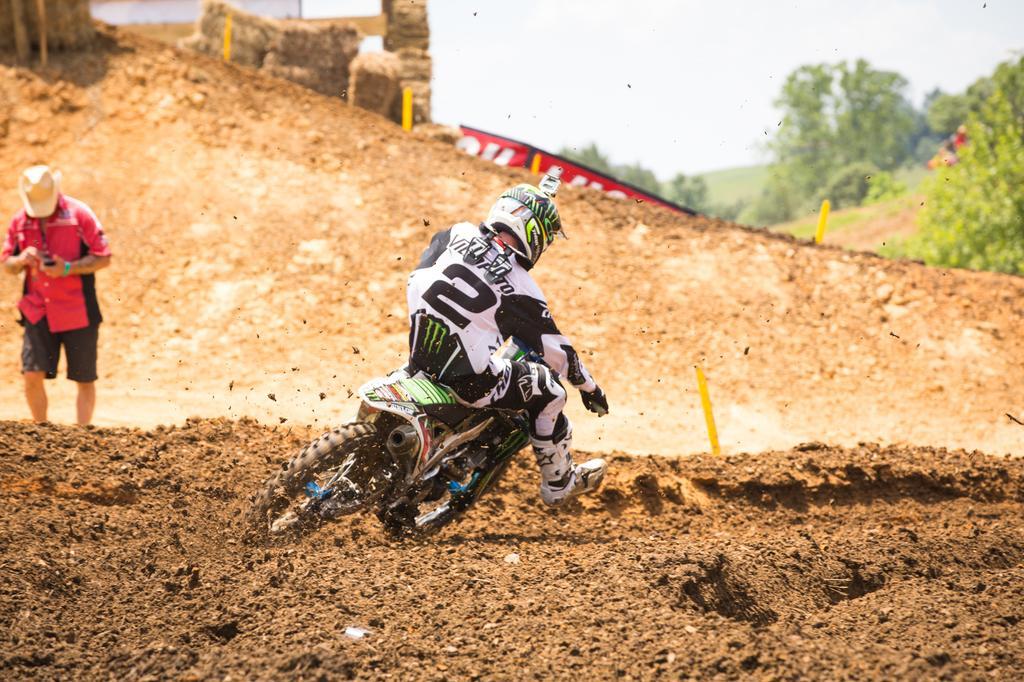Can you describe this image briefly? There are two people in the picture, the one is with red shirt and black short has a hat and the other one is riding the bicycle in the sandy way. This man has a helmet and a jacket and also some trees over there. 